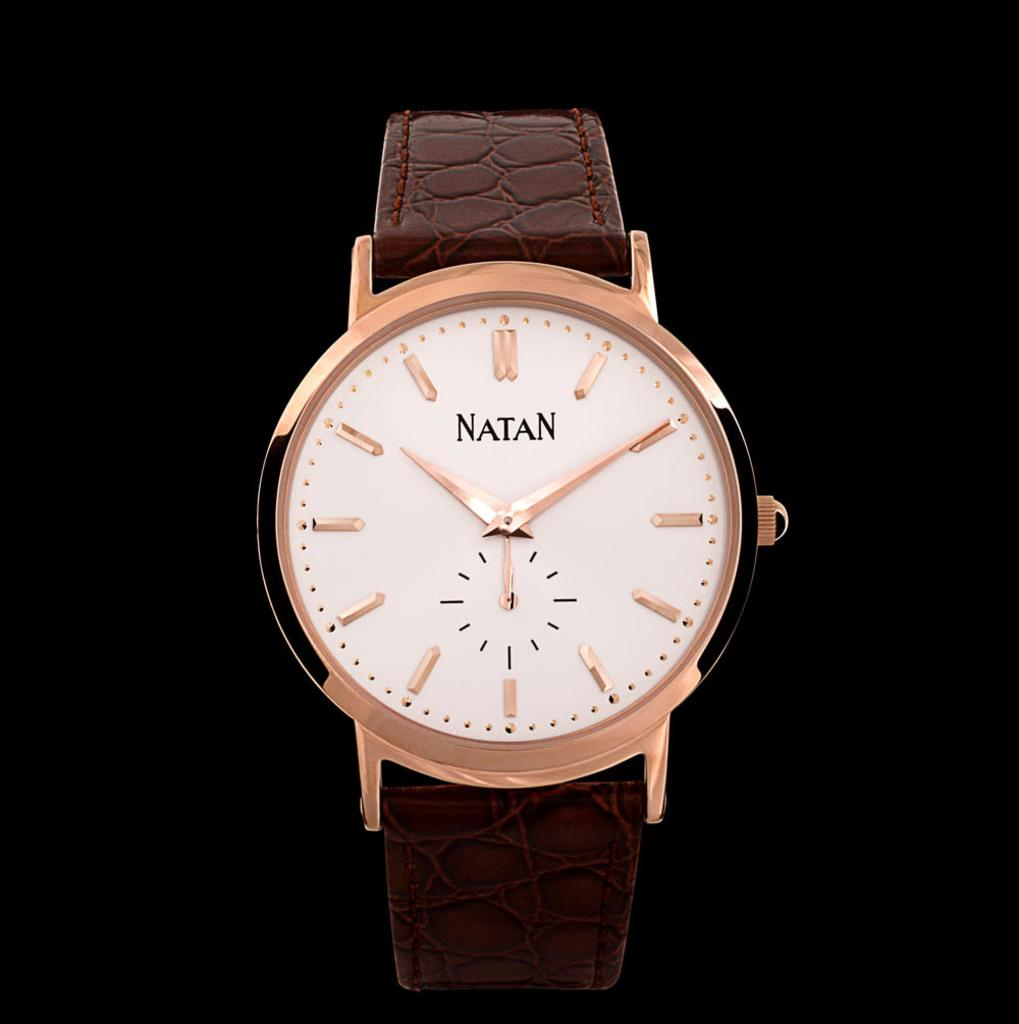Provide a one-sentence caption for the provided image. A watch with a brown band and gold trim that is the brand natan. 